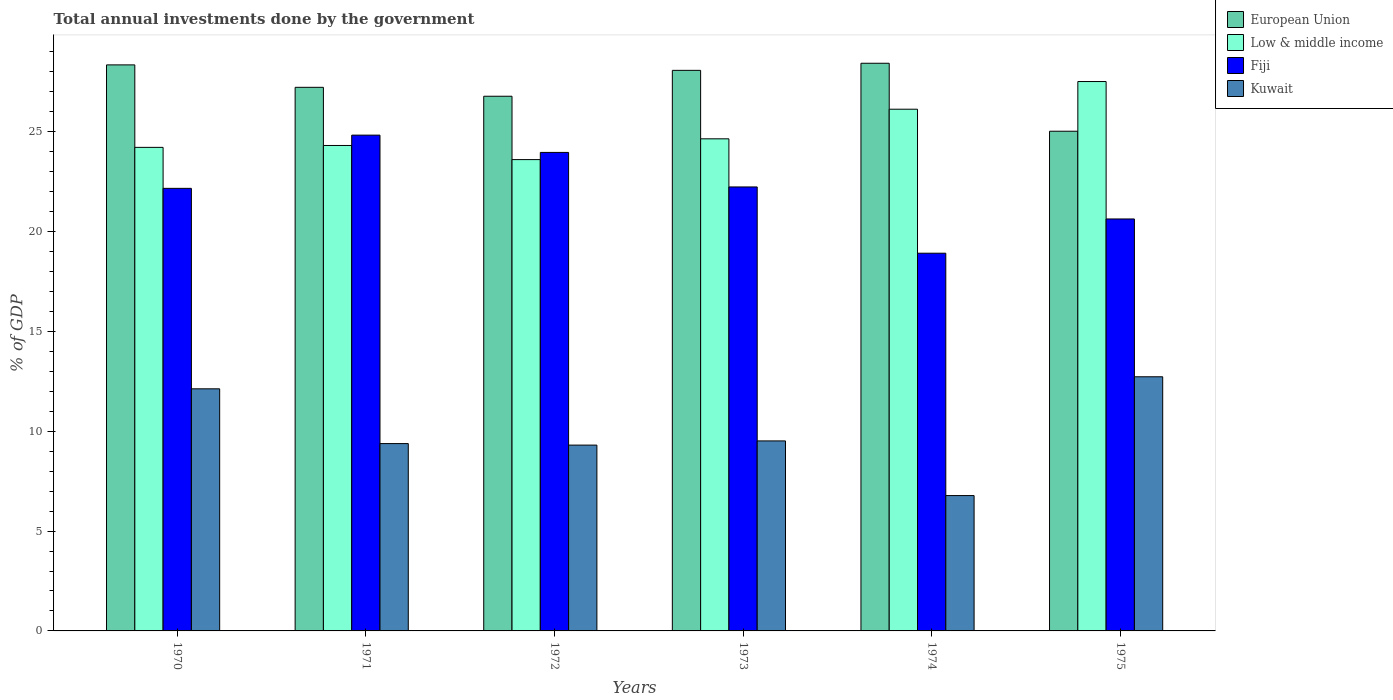How many different coloured bars are there?
Keep it short and to the point. 4. How many groups of bars are there?
Keep it short and to the point. 6. Are the number of bars on each tick of the X-axis equal?
Provide a succinct answer. Yes. How many bars are there on the 6th tick from the left?
Provide a short and direct response. 4. What is the total annual investments done by the government in Low & middle income in 1975?
Offer a terse response. 27.51. Across all years, what is the maximum total annual investments done by the government in Low & middle income?
Provide a short and direct response. 27.51. Across all years, what is the minimum total annual investments done by the government in Low & middle income?
Make the answer very short. 23.6. In which year was the total annual investments done by the government in Fiji maximum?
Make the answer very short. 1971. What is the total total annual investments done by the government in European Union in the graph?
Keep it short and to the point. 163.83. What is the difference between the total annual investments done by the government in European Union in 1970 and that in 1975?
Your answer should be compact. 3.32. What is the difference between the total annual investments done by the government in European Union in 1970 and the total annual investments done by the government in Kuwait in 1971?
Offer a very short reply. 18.96. What is the average total annual investments done by the government in Low & middle income per year?
Give a very brief answer. 25.06. In the year 1973, what is the difference between the total annual investments done by the government in Fiji and total annual investments done by the government in Low & middle income?
Your answer should be compact. -2.41. In how many years, is the total annual investments done by the government in European Union greater than 16 %?
Provide a succinct answer. 6. What is the ratio of the total annual investments done by the government in European Union in 1970 to that in 1974?
Keep it short and to the point. 1. What is the difference between the highest and the second highest total annual investments done by the government in European Union?
Give a very brief answer. 0.08. What is the difference between the highest and the lowest total annual investments done by the government in European Union?
Keep it short and to the point. 3.4. Is the sum of the total annual investments done by the government in European Union in 1971 and 1974 greater than the maximum total annual investments done by the government in Fiji across all years?
Your response must be concise. Yes. What does the 4th bar from the left in 1975 represents?
Your answer should be very brief. Kuwait. What does the 1st bar from the right in 1971 represents?
Give a very brief answer. Kuwait. How many bars are there?
Provide a succinct answer. 24. What is the difference between two consecutive major ticks on the Y-axis?
Give a very brief answer. 5. Does the graph contain grids?
Your answer should be very brief. No. How many legend labels are there?
Make the answer very short. 4. How are the legend labels stacked?
Your answer should be very brief. Vertical. What is the title of the graph?
Make the answer very short. Total annual investments done by the government. What is the label or title of the X-axis?
Give a very brief answer. Years. What is the label or title of the Y-axis?
Offer a terse response. % of GDP. What is the % of GDP of European Union in 1970?
Give a very brief answer. 28.34. What is the % of GDP of Low & middle income in 1970?
Give a very brief answer. 24.21. What is the % of GDP of Fiji in 1970?
Provide a succinct answer. 22.16. What is the % of GDP in Kuwait in 1970?
Offer a very short reply. 12.12. What is the % of GDP in European Union in 1971?
Your answer should be compact. 27.22. What is the % of GDP in Low & middle income in 1971?
Make the answer very short. 24.31. What is the % of GDP in Fiji in 1971?
Provide a succinct answer. 24.82. What is the % of GDP of Kuwait in 1971?
Make the answer very short. 9.38. What is the % of GDP in European Union in 1972?
Provide a short and direct response. 26.77. What is the % of GDP of Low & middle income in 1972?
Provide a short and direct response. 23.6. What is the % of GDP of Fiji in 1972?
Your answer should be very brief. 23.96. What is the % of GDP of Kuwait in 1972?
Your response must be concise. 9.3. What is the % of GDP in European Union in 1973?
Your answer should be compact. 28.07. What is the % of GDP in Low & middle income in 1973?
Offer a terse response. 24.64. What is the % of GDP of Fiji in 1973?
Your answer should be very brief. 22.23. What is the % of GDP of Kuwait in 1973?
Your response must be concise. 9.51. What is the % of GDP in European Union in 1974?
Give a very brief answer. 28.42. What is the % of GDP in Low & middle income in 1974?
Your response must be concise. 26.12. What is the % of GDP of Fiji in 1974?
Give a very brief answer. 18.91. What is the % of GDP in Kuwait in 1974?
Give a very brief answer. 6.78. What is the % of GDP in European Union in 1975?
Offer a terse response. 25.02. What is the % of GDP in Low & middle income in 1975?
Your answer should be compact. 27.51. What is the % of GDP in Fiji in 1975?
Your answer should be compact. 20.63. What is the % of GDP in Kuwait in 1975?
Provide a succinct answer. 12.72. Across all years, what is the maximum % of GDP of European Union?
Your answer should be compact. 28.42. Across all years, what is the maximum % of GDP in Low & middle income?
Your answer should be very brief. 27.51. Across all years, what is the maximum % of GDP in Fiji?
Your response must be concise. 24.82. Across all years, what is the maximum % of GDP of Kuwait?
Provide a succinct answer. 12.72. Across all years, what is the minimum % of GDP in European Union?
Keep it short and to the point. 25.02. Across all years, what is the minimum % of GDP in Low & middle income?
Offer a terse response. 23.6. Across all years, what is the minimum % of GDP of Fiji?
Keep it short and to the point. 18.91. Across all years, what is the minimum % of GDP of Kuwait?
Keep it short and to the point. 6.78. What is the total % of GDP in European Union in the graph?
Offer a terse response. 163.83. What is the total % of GDP of Low & middle income in the graph?
Ensure brevity in your answer.  150.38. What is the total % of GDP of Fiji in the graph?
Offer a terse response. 132.7. What is the total % of GDP in Kuwait in the graph?
Keep it short and to the point. 59.82. What is the difference between the % of GDP in European Union in 1970 and that in 1971?
Your answer should be compact. 1.12. What is the difference between the % of GDP in Low & middle income in 1970 and that in 1971?
Provide a short and direct response. -0.09. What is the difference between the % of GDP in Fiji in 1970 and that in 1971?
Offer a very short reply. -2.66. What is the difference between the % of GDP of Kuwait in 1970 and that in 1971?
Ensure brevity in your answer.  2.74. What is the difference between the % of GDP in European Union in 1970 and that in 1972?
Provide a short and direct response. 1.57. What is the difference between the % of GDP in Low & middle income in 1970 and that in 1972?
Make the answer very short. 0.61. What is the difference between the % of GDP of Fiji in 1970 and that in 1972?
Ensure brevity in your answer.  -1.8. What is the difference between the % of GDP in Kuwait in 1970 and that in 1972?
Give a very brief answer. 2.82. What is the difference between the % of GDP in European Union in 1970 and that in 1973?
Offer a terse response. 0.27. What is the difference between the % of GDP in Low & middle income in 1970 and that in 1973?
Your response must be concise. -0.43. What is the difference between the % of GDP in Fiji in 1970 and that in 1973?
Offer a very short reply. -0.07. What is the difference between the % of GDP in Kuwait in 1970 and that in 1973?
Provide a short and direct response. 2.61. What is the difference between the % of GDP of European Union in 1970 and that in 1974?
Provide a succinct answer. -0.08. What is the difference between the % of GDP in Low & middle income in 1970 and that in 1974?
Keep it short and to the point. -1.91. What is the difference between the % of GDP in Fiji in 1970 and that in 1974?
Provide a short and direct response. 3.25. What is the difference between the % of GDP of Kuwait in 1970 and that in 1974?
Give a very brief answer. 5.34. What is the difference between the % of GDP of European Union in 1970 and that in 1975?
Ensure brevity in your answer.  3.32. What is the difference between the % of GDP in Low & middle income in 1970 and that in 1975?
Make the answer very short. -3.3. What is the difference between the % of GDP in Fiji in 1970 and that in 1975?
Provide a short and direct response. 1.53. What is the difference between the % of GDP of Kuwait in 1970 and that in 1975?
Provide a short and direct response. -0.6. What is the difference between the % of GDP of European Union in 1971 and that in 1972?
Provide a short and direct response. 0.45. What is the difference between the % of GDP of Low & middle income in 1971 and that in 1972?
Ensure brevity in your answer.  0.71. What is the difference between the % of GDP in Fiji in 1971 and that in 1972?
Ensure brevity in your answer.  0.87. What is the difference between the % of GDP of Kuwait in 1971 and that in 1972?
Give a very brief answer. 0.08. What is the difference between the % of GDP in European Union in 1971 and that in 1973?
Ensure brevity in your answer.  -0.85. What is the difference between the % of GDP in Low & middle income in 1971 and that in 1973?
Ensure brevity in your answer.  -0.33. What is the difference between the % of GDP of Fiji in 1971 and that in 1973?
Offer a very short reply. 2.59. What is the difference between the % of GDP in Kuwait in 1971 and that in 1973?
Provide a short and direct response. -0.13. What is the difference between the % of GDP in European Union in 1971 and that in 1974?
Keep it short and to the point. -1.21. What is the difference between the % of GDP in Low & middle income in 1971 and that in 1974?
Provide a succinct answer. -1.82. What is the difference between the % of GDP of Fiji in 1971 and that in 1974?
Give a very brief answer. 5.91. What is the difference between the % of GDP in Kuwait in 1971 and that in 1974?
Keep it short and to the point. 2.6. What is the difference between the % of GDP of European Union in 1971 and that in 1975?
Offer a very short reply. 2.2. What is the difference between the % of GDP of Low & middle income in 1971 and that in 1975?
Give a very brief answer. -3.2. What is the difference between the % of GDP in Fiji in 1971 and that in 1975?
Your response must be concise. 4.2. What is the difference between the % of GDP in Kuwait in 1971 and that in 1975?
Give a very brief answer. -3.35. What is the difference between the % of GDP of European Union in 1972 and that in 1973?
Make the answer very short. -1.3. What is the difference between the % of GDP of Low & middle income in 1972 and that in 1973?
Make the answer very short. -1.04. What is the difference between the % of GDP of Fiji in 1972 and that in 1973?
Make the answer very short. 1.73. What is the difference between the % of GDP of Kuwait in 1972 and that in 1973?
Your answer should be compact. -0.21. What is the difference between the % of GDP of European Union in 1972 and that in 1974?
Provide a short and direct response. -1.65. What is the difference between the % of GDP of Low & middle income in 1972 and that in 1974?
Ensure brevity in your answer.  -2.52. What is the difference between the % of GDP of Fiji in 1972 and that in 1974?
Provide a succinct answer. 5.05. What is the difference between the % of GDP of Kuwait in 1972 and that in 1974?
Your answer should be compact. 2.53. What is the difference between the % of GDP of European Union in 1972 and that in 1975?
Keep it short and to the point. 1.75. What is the difference between the % of GDP of Low & middle income in 1972 and that in 1975?
Offer a terse response. -3.91. What is the difference between the % of GDP in Fiji in 1972 and that in 1975?
Provide a short and direct response. 3.33. What is the difference between the % of GDP in Kuwait in 1972 and that in 1975?
Keep it short and to the point. -3.42. What is the difference between the % of GDP in European Union in 1973 and that in 1974?
Give a very brief answer. -0.36. What is the difference between the % of GDP of Low & middle income in 1973 and that in 1974?
Your answer should be very brief. -1.48. What is the difference between the % of GDP of Fiji in 1973 and that in 1974?
Provide a short and direct response. 3.32. What is the difference between the % of GDP of Kuwait in 1973 and that in 1974?
Provide a succinct answer. 2.74. What is the difference between the % of GDP in European Union in 1973 and that in 1975?
Ensure brevity in your answer.  3.05. What is the difference between the % of GDP in Low & middle income in 1973 and that in 1975?
Make the answer very short. -2.87. What is the difference between the % of GDP of Fiji in 1973 and that in 1975?
Offer a terse response. 1.6. What is the difference between the % of GDP of Kuwait in 1973 and that in 1975?
Your answer should be compact. -3.21. What is the difference between the % of GDP of European Union in 1974 and that in 1975?
Provide a succinct answer. 3.4. What is the difference between the % of GDP in Low & middle income in 1974 and that in 1975?
Provide a succinct answer. -1.39. What is the difference between the % of GDP in Fiji in 1974 and that in 1975?
Give a very brief answer. -1.71. What is the difference between the % of GDP in Kuwait in 1974 and that in 1975?
Offer a very short reply. -5.95. What is the difference between the % of GDP in European Union in 1970 and the % of GDP in Low & middle income in 1971?
Offer a terse response. 4.03. What is the difference between the % of GDP in European Union in 1970 and the % of GDP in Fiji in 1971?
Your answer should be compact. 3.52. What is the difference between the % of GDP of European Union in 1970 and the % of GDP of Kuwait in 1971?
Make the answer very short. 18.96. What is the difference between the % of GDP of Low & middle income in 1970 and the % of GDP of Fiji in 1971?
Offer a terse response. -0.61. What is the difference between the % of GDP of Low & middle income in 1970 and the % of GDP of Kuwait in 1971?
Offer a terse response. 14.83. What is the difference between the % of GDP in Fiji in 1970 and the % of GDP in Kuwait in 1971?
Offer a very short reply. 12.78. What is the difference between the % of GDP in European Union in 1970 and the % of GDP in Low & middle income in 1972?
Offer a very short reply. 4.74. What is the difference between the % of GDP of European Union in 1970 and the % of GDP of Fiji in 1972?
Keep it short and to the point. 4.38. What is the difference between the % of GDP in European Union in 1970 and the % of GDP in Kuwait in 1972?
Keep it short and to the point. 19.04. What is the difference between the % of GDP of Low & middle income in 1970 and the % of GDP of Fiji in 1972?
Give a very brief answer. 0.25. What is the difference between the % of GDP in Low & middle income in 1970 and the % of GDP in Kuwait in 1972?
Your answer should be very brief. 14.91. What is the difference between the % of GDP of Fiji in 1970 and the % of GDP of Kuwait in 1972?
Give a very brief answer. 12.86. What is the difference between the % of GDP in European Union in 1970 and the % of GDP in Low & middle income in 1973?
Provide a short and direct response. 3.7. What is the difference between the % of GDP in European Union in 1970 and the % of GDP in Fiji in 1973?
Your response must be concise. 6.11. What is the difference between the % of GDP in European Union in 1970 and the % of GDP in Kuwait in 1973?
Your answer should be very brief. 18.83. What is the difference between the % of GDP of Low & middle income in 1970 and the % of GDP of Fiji in 1973?
Keep it short and to the point. 1.98. What is the difference between the % of GDP of Low & middle income in 1970 and the % of GDP of Kuwait in 1973?
Offer a terse response. 14.7. What is the difference between the % of GDP in Fiji in 1970 and the % of GDP in Kuwait in 1973?
Keep it short and to the point. 12.65. What is the difference between the % of GDP of European Union in 1970 and the % of GDP of Low & middle income in 1974?
Offer a terse response. 2.22. What is the difference between the % of GDP of European Union in 1970 and the % of GDP of Fiji in 1974?
Offer a very short reply. 9.43. What is the difference between the % of GDP of European Union in 1970 and the % of GDP of Kuwait in 1974?
Your response must be concise. 21.56. What is the difference between the % of GDP in Low & middle income in 1970 and the % of GDP in Fiji in 1974?
Your answer should be compact. 5.3. What is the difference between the % of GDP of Low & middle income in 1970 and the % of GDP of Kuwait in 1974?
Provide a succinct answer. 17.43. What is the difference between the % of GDP in Fiji in 1970 and the % of GDP in Kuwait in 1974?
Offer a very short reply. 15.38. What is the difference between the % of GDP in European Union in 1970 and the % of GDP in Low & middle income in 1975?
Provide a short and direct response. 0.83. What is the difference between the % of GDP in European Union in 1970 and the % of GDP in Fiji in 1975?
Make the answer very short. 7.71. What is the difference between the % of GDP in European Union in 1970 and the % of GDP in Kuwait in 1975?
Ensure brevity in your answer.  15.62. What is the difference between the % of GDP in Low & middle income in 1970 and the % of GDP in Fiji in 1975?
Keep it short and to the point. 3.58. What is the difference between the % of GDP of Low & middle income in 1970 and the % of GDP of Kuwait in 1975?
Keep it short and to the point. 11.49. What is the difference between the % of GDP of Fiji in 1970 and the % of GDP of Kuwait in 1975?
Your response must be concise. 9.43. What is the difference between the % of GDP of European Union in 1971 and the % of GDP of Low & middle income in 1972?
Provide a succinct answer. 3.62. What is the difference between the % of GDP in European Union in 1971 and the % of GDP in Fiji in 1972?
Ensure brevity in your answer.  3.26. What is the difference between the % of GDP in European Union in 1971 and the % of GDP in Kuwait in 1972?
Your response must be concise. 17.91. What is the difference between the % of GDP of Low & middle income in 1971 and the % of GDP of Fiji in 1972?
Your answer should be compact. 0.35. What is the difference between the % of GDP in Low & middle income in 1971 and the % of GDP in Kuwait in 1972?
Offer a terse response. 15. What is the difference between the % of GDP in Fiji in 1971 and the % of GDP in Kuwait in 1972?
Keep it short and to the point. 15.52. What is the difference between the % of GDP in European Union in 1971 and the % of GDP in Low & middle income in 1973?
Give a very brief answer. 2.58. What is the difference between the % of GDP in European Union in 1971 and the % of GDP in Fiji in 1973?
Offer a very short reply. 4.99. What is the difference between the % of GDP in European Union in 1971 and the % of GDP in Kuwait in 1973?
Provide a short and direct response. 17.7. What is the difference between the % of GDP in Low & middle income in 1971 and the % of GDP in Fiji in 1973?
Give a very brief answer. 2.08. What is the difference between the % of GDP of Low & middle income in 1971 and the % of GDP of Kuwait in 1973?
Make the answer very short. 14.79. What is the difference between the % of GDP in Fiji in 1971 and the % of GDP in Kuwait in 1973?
Provide a short and direct response. 15.31. What is the difference between the % of GDP in European Union in 1971 and the % of GDP in Low & middle income in 1974?
Your answer should be compact. 1.1. What is the difference between the % of GDP in European Union in 1971 and the % of GDP in Fiji in 1974?
Your answer should be very brief. 8.31. What is the difference between the % of GDP of European Union in 1971 and the % of GDP of Kuwait in 1974?
Offer a terse response. 20.44. What is the difference between the % of GDP of Low & middle income in 1971 and the % of GDP of Fiji in 1974?
Your response must be concise. 5.39. What is the difference between the % of GDP of Low & middle income in 1971 and the % of GDP of Kuwait in 1974?
Provide a succinct answer. 17.53. What is the difference between the % of GDP of Fiji in 1971 and the % of GDP of Kuwait in 1974?
Your answer should be very brief. 18.05. What is the difference between the % of GDP of European Union in 1971 and the % of GDP of Low & middle income in 1975?
Your answer should be compact. -0.29. What is the difference between the % of GDP in European Union in 1971 and the % of GDP in Fiji in 1975?
Your answer should be very brief. 6.59. What is the difference between the % of GDP in European Union in 1971 and the % of GDP in Kuwait in 1975?
Give a very brief answer. 14.49. What is the difference between the % of GDP in Low & middle income in 1971 and the % of GDP in Fiji in 1975?
Give a very brief answer. 3.68. What is the difference between the % of GDP of Low & middle income in 1971 and the % of GDP of Kuwait in 1975?
Provide a succinct answer. 11.58. What is the difference between the % of GDP in Fiji in 1971 and the % of GDP in Kuwait in 1975?
Provide a succinct answer. 12.1. What is the difference between the % of GDP in European Union in 1972 and the % of GDP in Low & middle income in 1973?
Your answer should be compact. 2.13. What is the difference between the % of GDP of European Union in 1972 and the % of GDP of Fiji in 1973?
Provide a short and direct response. 4.54. What is the difference between the % of GDP in European Union in 1972 and the % of GDP in Kuwait in 1973?
Ensure brevity in your answer.  17.26. What is the difference between the % of GDP in Low & middle income in 1972 and the % of GDP in Fiji in 1973?
Give a very brief answer. 1.37. What is the difference between the % of GDP of Low & middle income in 1972 and the % of GDP of Kuwait in 1973?
Provide a succinct answer. 14.08. What is the difference between the % of GDP in Fiji in 1972 and the % of GDP in Kuwait in 1973?
Keep it short and to the point. 14.44. What is the difference between the % of GDP in European Union in 1972 and the % of GDP in Low & middle income in 1974?
Give a very brief answer. 0.65. What is the difference between the % of GDP in European Union in 1972 and the % of GDP in Fiji in 1974?
Ensure brevity in your answer.  7.86. What is the difference between the % of GDP in European Union in 1972 and the % of GDP in Kuwait in 1974?
Your response must be concise. 19.99. What is the difference between the % of GDP in Low & middle income in 1972 and the % of GDP in Fiji in 1974?
Your response must be concise. 4.69. What is the difference between the % of GDP of Low & middle income in 1972 and the % of GDP of Kuwait in 1974?
Your answer should be very brief. 16.82. What is the difference between the % of GDP of Fiji in 1972 and the % of GDP of Kuwait in 1974?
Your response must be concise. 17.18. What is the difference between the % of GDP in European Union in 1972 and the % of GDP in Low & middle income in 1975?
Provide a short and direct response. -0.74. What is the difference between the % of GDP of European Union in 1972 and the % of GDP of Fiji in 1975?
Your answer should be very brief. 6.14. What is the difference between the % of GDP of European Union in 1972 and the % of GDP of Kuwait in 1975?
Make the answer very short. 14.05. What is the difference between the % of GDP of Low & middle income in 1972 and the % of GDP of Fiji in 1975?
Keep it short and to the point. 2.97. What is the difference between the % of GDP in Low & middle income in 1972 and the % of GDP in Kuwait in 1975?
Provide a short and direct response. 10.87. What is the difference between the % of GDP of Fiji in 1972 and the % of GDP of Kuwait in 1975?
Provide a short and direct response. 11.23. What is the difference between the % of GDP in European Union in 1973 and the % of GDP in Low & middle income in 1974?
Provide a short and direct response. 1.95. What is the difference between the % of GDP of European Union in 1973 and the % of GDP of Fiji in 1974?
Your response must be concise. 9.15. What is the difference between the % of GDP of European Union in 1973 and the % of GDP of Kuwait in 1974?
Give a very brief answer. 21.29. What is the difference between the % of GDP in Low & middle income in 1973 and the % of GDP in Fiji in 1974?
Offer a terse response. 5.73. What is the difference between the % of GDP in Low & middle income in 1973 and the % of GDP in Kuwait in 1974?
Your answer should be very brief. 17.86. What is the difference between the % of GDP of Fiji in 1973 and the % of GDP of Kuwait in 1974?
Give a very brief answer. 15.45. What is the difference between the % of GDP of European Union in 1973 and the % of GDP of Low & middle income in 1975?
Offer a very short reply. 0.56. What is the difference between the % of GDP in European Union in 1973 and the % of GDP in Fiji in 1975?
Offer a very short reply. 7.44. What is the difference between the % of GDP of European Union in 1973 and the % of GDP of Kuwait in 1975?
Keep it short and to the point. 15.34. What is the difference between the % of GDP of Low & middle income in 1973 and the % of GDP of Fiji in 1975?
Ensure brevity in your answer.  4.01. What is the difference between the % of GDP in Low & middle income in 1973 and the % of GDP in Kuwait in 1975?
Offer a terse response. 11.91. What is the difference between the % of GDP in Fiji in 1973 and the % of GDP in Kuwait in 1975?
Give a very brief answer. 9.5. What is the difference between the % of GDP of European Union in 1974 and the % of GDP of Low & middle income in 1975?
Give a very brief answer. 0.92. What is the difference between the % of GDP in European Union in 1974 and the % of GDP in Fiji in 1975?
Make the answer very short. 7.8. What is the difference between the % of GDP in European Union in 1974 and the % of GDP in Kuwait in 1975?
Provide a short and direct response. 15.7. What is the difference between the % of GDP of Low & middle income in 1974 and the % of GDP of Fiji in 1975?
Offer a terse response. 5.49. What is the difference between the % of GDP of Low & middle income in 1974 and the % of GDP of Kuwait in 1975?
Make the answer very short. 13.4. What is the difference between the % of GDP in Fiji in 1974 and the % of GDP in Kuwait in 1975?
Your answer should be compact. 6.19. What is the average % of GDP in European Union per year?
Offer a very short reply. 27.31. What is the average % of GDP of Low & middle income per year?
Ensure brevity in your answer.  25.06. What is the average % of GDP in Fiji per year?
Your answer should be very brief. 22.12. What is the average % of GDP of Kuwait per year?
Provide a short and direct response. 9.97. In the year 1970, what is the difference between the % of GDP in European Union and % of GDP in Low & middle income?
Provide a succinct answer. 4.13. In the year 1970, what is the difference between the % of GDP of European Union and % of GDP of Fiji?
Provide a short and direct response. 6.18. In the year 1970, what is the difference between the % of GDP of European Union and % of GDP of Kuwait?
Keep it short and to the point. 16.22. In the year 1970, what is the difference between the % of GDP of Low & middle income and % of GDP of Fiji?
Your answer should be compact. 2.05. In the year 1970, what is the difference between the % of GDP of Low & middle income and % of GDP of Kuwait?
Offer a terse response. 12.09. In the year 1970, what is the difference between the % of GDP of Fiji and % of GDP of Kuwait?
Keep it short and to the point. 10.04. In the year 1971, what is the difference between the % of GDP of European Union and % of GDP of Low & middle income?
Give a very brief answer. 2.91. In the year 1971, what is the difference between the % of GDP in European Union and % of GDP in Fiji?
Ensure brevity in your answer.  2.39. In the year 1971, what is the difference between the % of GDP of European Union and % of GDP of Kuwait?
Keep it short and to the point. 17.84. In the year 1971, what is the difference between the % of GDP of Low & middle income and % of GDP of Fiji?
Provide a succinct answer. -0.52. In the year 1971, what is the difference between the % of GDP in Low & middle income and % of GDP in Kuwait?
Your answer should be very brief. 14.93. In the year 1971, what is the difference between the % of GDP of Fiji and % of GDP of Kuwait?
Your response must be concise. 15.44. In the year 1972, what is the difference between the % of GDP of European Union and % of GDP of Low & middle income?
Offer a very short reply. 3.17. In the year 1972, what is the difference between the % of GDP of European Union and % of GDP of Fiji?
Ensure brevity in your answer.  2.81. In the year 1972, what is the difference between the % of GDP of European Union and % of GDP of Kuwait?
Give a very brief answer. 17.47. In the year 1972, what is the difference between the % of GDP in Low & middle income and % of GDP in Fiji?
Give a very brief answer. -0.36. In the year 1972, what is the difference between the % of GDP of Low & middle income and % of GDP of Kuwait?
Your answer should be compact. 14.29. In the year 1972, what is the difference between the % of GDP of Fiji and % of GDP of Kuwait?
Offer a terse response. 14.65. In the year 1973, what is the difference between the % of GDP of European Union and % of GDP of Low & middle income?
Provide a short and direct response. 3.43. In the year 1973, what is the difference between the % of GDP in European Union and % of GDP in Fiji?
Give a very brief answer. 5.84. In the year 1973, what is the difference between the % of GDP in European Union and % of GDP in Kuwait?
Offer a very short reply. 18.55. In the year 1973, what is the difference between the % of GDP of Low & middle income and % of GDP of Fiji?
Your answer should be very brief. 2.41. In the year 1973, what is the difference between the % of GDP of Low & middle income and % of GDP of Kuwait?
Make the answer very short. 15.12. In the year 1973, what is the difference between the % of GDP of Fiji and % of GDP of Kuwait?
Provide a short and direct response. 12.72. In the year 1974, what is the difference between the % of GDP of European Union and % of GDP of Low & middle income?
Your answer should be very brief. 2.3. In the year 1974, what is the difference between the % of GDP of European Union and % of GDP of Fiji?
Keep it short and to the point. 9.51. In the year 1974, what is the difference between the % of GDP of European Union and % of GDP of Kuwait?
Keep it short and to the point. 21.64. In the year 1974, what is the difference between the % of GDP in Low & middle income and % of GDP in Fiji?
Keep it short and to the point. 7.21. In the year 1974, what is the difference between the % of GDP in Low & middle income and % of GDP in Kuwait?
Make the answer very short. 19.34. In the year 1974, what is the difference between the % of GDP of Fiji and % of GDP of Kuwait?
Offer a terse response. 12.13. In the year 1975, what is the difference between the % of GDP of European Union and % of GDP of Low & middle income?
Offer a very short reply. -2.49. In the year 1975, what is the difference between the % of GDP of European Union and % of GDP of Fiji?
Keep it short and to the point. 4.39. In the year 1975, what is the difference between the % of GDP in European Union and % of GDP in Kuwait?
Give a very brief answer. 12.29. In the year 1975, what is the difference between the % of GDP in Low & middle income and % of GDP in Fiji?
Offer a very short reply. 6.88. In the year 1975, what is the difference between the % of GDP in Low & middle income and % of GDP in Kuwait?
Keep it short and to the point. 14.78. In the year 1975, what is the difference between the % of GDP in Fiji and % of GDP in Kuwait?
Your response must be concise. 7.9. What is the ratio of the % of GDP in European Union in 1970 to that in 1971?
Your response must be concise. 1.04. What is the ratio of the % of GDP of Low & middle income in 1970 to that in 1971?
Offer a very short reply. 1. What is the ratio of the % of GDP of Fiji in 1970 to that in 1971?
Keep it short and to the point. 0.89. What is the ratio of the % of GDP of Kuwait in 1970 to that in 1971?
Provide a short and direct response. 1.29. What is the ratio of the % of GDP of European Union in 1970 to that in 1972?
Ensure brevity in your answer.  1.06. What is the ratio of the % of GDP in Fiji in 1970 to that in 1972?
Your response must be concise. 0.92. What is the ratio of the % of GDP in Kuwait in 1970 to that in 1972?
Offer a very short reply. 1.3. What is the ratio of the % of GDP in European Union in 1970 to that in 1973?
Keep it short and to the point. 1.01. What is the ratio of the % of GDP of Low & middle income in 1970 to that in 1973?
Offer a terse response. 0.98. What is the ratio of the % of GDP of Fiji in 1970 to that in 1973?
Offer a very short reply. 1. What is the ratio of the % of GDP in Kuwait in 1970 to that in 1973?
Provide a short and direct response. 1.27. What is the ratio of the % of GDP in Low & middle income in 1970 to that in 1974?
Offer a very short reply. 0.93. What is the ratio of the % of GDP in Fiji in 1970 to that in 1974?
Offer a terse response. 1.17. What is the ratio of the % of GDP in Kuwait in 1970 to that in 1974?
Your answer should be very brief. 1.79. What is the ratio of the % of GDP in European Union in 1970 to that in 1975?
Provide a short and direct response. 1.13. What is the ratio of the % of GDP in Low & middle income in 1970 to that in 1975?
Your response must be concise. 0.88. What is the ratio of the % of GDP in Fiji in 1970 to that in 1975?
Ensure brevity in your answer.  1.07. What is the ratio of the % of GDP of Kuwait in 1970 to that in 1975?
Provide a succinct answer. 0.95. What is the ratio of the % of GDP of European Union in 1971 to that in 1972?
Make the answer very short. 1.02. What is the ratio of the % of GDP in Fiji in 1971 to that in 1972?
Keep it short and to the point. 1.04. What is the ratio of the % of GDP of Kuwait in 1971 to that in 1972?
Keep it short and to the point. 1.01. What is the ratio of the % of GDP in European Union in 1971 to that in 1973?
Ensure brevity in your answer.  0.97. What is the ratio of the % of GDP in Low & middle income in 1971 to that in 1973?
Provide a succinct answer. 0.99. What is the ratio of the % of GDP in Fiji in 1971 to that in 1973?
Provide a succinct answer. 1.12. What is the ratio of the % of GDP of Kuwait in 1971 to that in 1973?
Your answer should be very brief. 0.99. What is the ratio of the % of GDP of European Union in 1971 to that in 1974?
Make the answer very short. 0.96. What is the ratio of the % of GDP of Low & middle income in 1971 to that in 1974?
Keep it short and to the point. 0.93. What is the ratio of the % of GDP in Fiji in 1971 to that in 1974?
Provide a succinct answer. 1.31. What is the ratio of the % of GDP of Kuwait in 1971 to that in 1974?
Offer a very short reply. 1.38. What is the ratio of the % of GDP of European Union in 1971 to that in 1975?
Your response must be concise. 1.09. What is the ratio of the % of GDP in Low & middle income in 1971 to that in 1975?
Your response must be concise. 0.88. What is the ratio of the % of GDP of Fiji in 1971 to that in 1975?
Keep it short and to the point. 1.2. What is the ratio of the % of GDP of Kuwait in 1971 to that in 1975?
Keep it short and to the point. 0.74. What is the ratio of the % of GDP in European Union in 1972 to that in 1973?
Your answer should be compact. 0.95. What is the ratio of the % of GDP in Low & middle income in 1972 to that in 1973?
Keep it short and to the point. 0.96. What is the ratio of the % of GDP in Fiji in 1972 to that in 1973?
Ensure brevity in your answer.  1.08. What is the ratio of the % of GDP of Kuwait in 1972 to that in 1973?
Your response must be concise. 0.98. What is the ratio of the % of GDP in European Union in 1972 to that in 1974?
Give a very brief answer. 0.94. What is the ratio of the % of GDP in Low & middle income in 1972 to that in 1974?
Provide a succinct answer. 0.9. What is the ratio of the % of GDP of Fiji in 1972 to that in 1974?
Make the answer very short. 1.27. What is the ratio of the % of GDP of Kuwait in 1972 to that in 1974?
Ensure brevity in your answer.  1.37. What is the ratio of the % of GDP of European Union in 1972 to that in 1975?
Your answer should be compact. 1.07. What is the ratio of the % of GDP in Low & middle income in 1972 to that in 1975?
Ensure brevity in your answer.  0.86. What is the ratio of the % of GDP of Fiji in 1972 to that in 1975?
Your answer should be compact. 1.16. What is the ratio of the % of GDP in Kuwait in 1972 to that in 1975?
Provide a succinct answer. 0.73. What is the ratio of the % of GDP in European Union in 1973 to that in 1974?
Keep it short and to the point. 0.99. What is the ratio of the % of GDP in Low & middle income in 1973 to that in 1974?
Provide a succinct answer. 0.94. What is the ratio of the % of GDP in Fiji in 1973 to that in 1974?
Ensure brevity in your answer.  1.18. What is the ratio of the % of GDP in Kuwait in 1973 to that in 1974?
Provide a succinct answer. 1.4. What is the ratio of the % of GDP in European Union in 1973 to that in 1975?
Your answer should be very brief. 1.12. What is the ratio of the % of GDP in Low & middle income in 1973 to that in 1975?
Ensure brevity in your answer.  0.9. What is the ratio of the % of GDP in Fiji in 1973 to that in 1975?
Offer a very short reply. 1.08. What is the ratio of the % of GDP in Kuwait in 1973 to that in 1975?
Your response must be concise. 0.75. What is the ratio of the % of GDP of European Union in 1974 to that in 1975?
Provide a succinct answer. 1.14. What is the ratio of the % of GDP of Low & middle income in 1974 to that in 1975?
Make the answer very short. 0.95. What is the ratio of the % of GDP in Fiji in 1974 to that in 1975?
Make the answer very short. 0.92. What is the ratio of the % of GDP in Kuwait in 1974 to that in 1975?
Ensure brevity in your answer.  0.53. What is the difference between the highest and the second highest % of GDP of European Union?
Keep it short and to the point. 0.08. What is the difference between the highest and the second highest % of GDP in Low & middle income?
Provide a succinct answer. 1.39. What is the difference between the highest and the second highest % of GDP of Fiji?
Ensure brevity in your answer.  0.87. What is the difference between the highest and the second highest % of GDP in Kuwait?
Make the answer very short. 0.6. What is the difference between the highest and the lowest % of GDP in European Union?
Offer a terse response. 3.4. What is the difference between the highest and the lowest % of GDP in Low & middle income?
Offer a terse response. 3.91. What is the difference between the highest and the lowest % of GDP of Fiji?
Offer a very short reply. 5.91. What is the difference between the highest and the lowest % of GDP in Kuwait?
Provide a short and direct response. 5.95. 